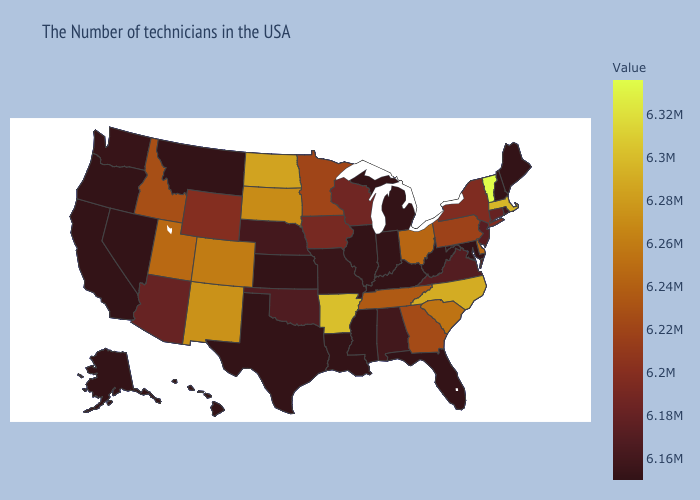Among the states that border New York , which have the highest value?
Be succinct. Vermont. Does Hawaii have a higher value than Tennessee?
Keep it brief. No. Among the states that border Montana , which have the lowest value?
Be succinct. Wyoming. Is the legend a continuous bar?
Quick response, please. Yes. Does Vermont have a higher value than Colorado?
Give a very brief answer. Yes. Among the states that border California , does Nevada have the lowest value?
Answer briefly. Yes. Does Indiana have the lowest value in the USA?
Short answer required. Yes. 